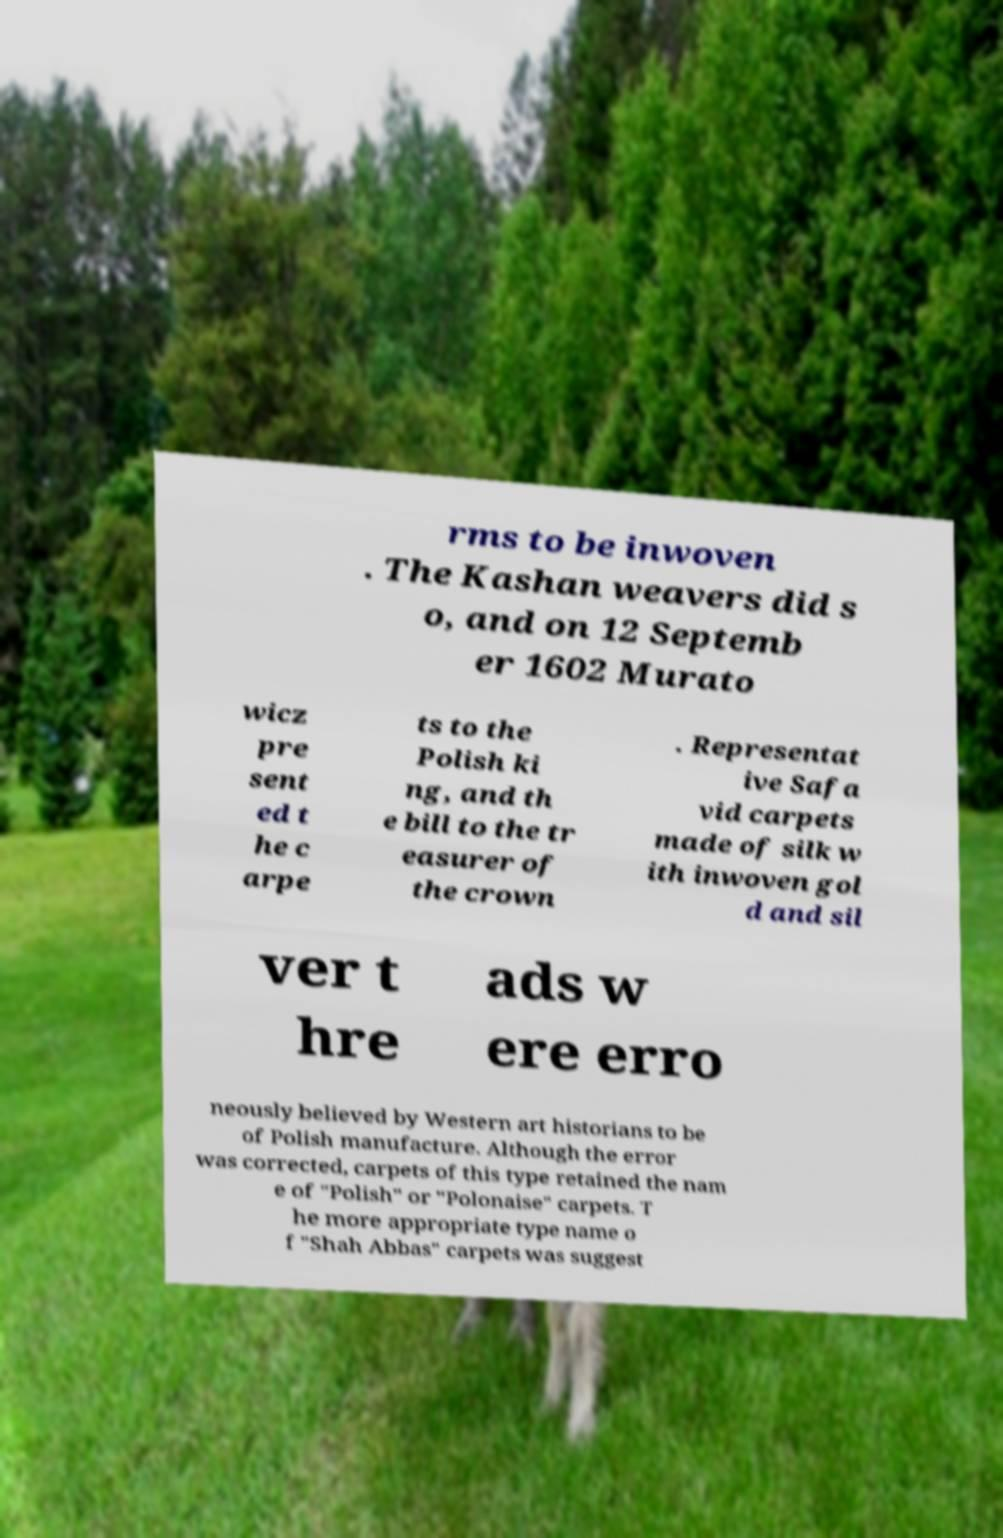What messages or text are displayed in this image? I need them in a readable, typed format. rms to be inwoven . The Kashan weavers did s o, and on 12 Septemb er 1602 Murato wicz pre sent ed t he c arpe ts to the Polish ki ng, and th e bill to the tr easurer of the crown . Representat ive Safa vid carpets made of silk w ith inwoven gol d and sil ver t hre ads w ere erro neously believed by Western art historians to be of Polish manufacture. Although the error was corrected, carpets of this type retained the nam e of "Polish" or "Polonaise" carpets. T he more appropriate type name o f "Shah Abbas" carpets was suggest 